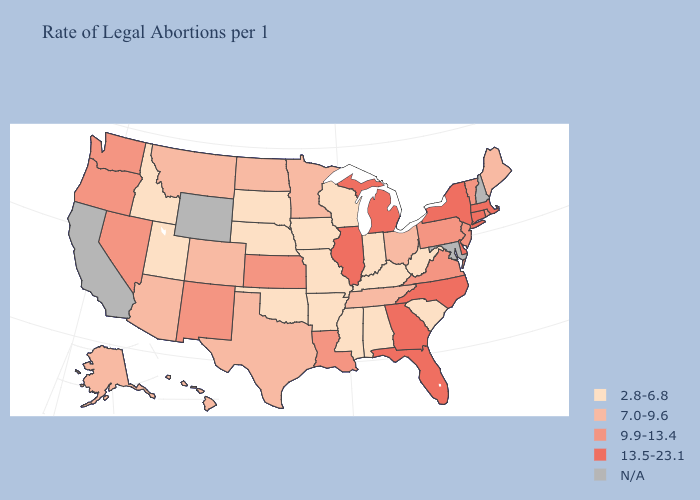Which states hav the highest value in the MidWest?
Answer briefly. Illinois, Michigan. Which states have the lowest value in the Northeast?
Keep it brief. Maine. What is the lowest value in states that border New Mexico?
Quick response, please. 2.8-6.8. What is the highest value in the West ?
Quick response, please. 9.9-13.4. Name the states that have a value in the range 7.0-9.6?
Keep it brief. Alaska, Arizona, Colorado, Hawaii, Maine, Minnesota, Montana, North Dakota, Ohio, Tennessee, Texas. Among the states that border New Mexico , which have the highest value?
Be succinct. Arizona, Colorado, Texas. Which states hav the highest value in the West?
Answer briefly. Nevada, New Mexico, Oregon, Washington. What is the value of Arkansas?
Short answer required. 2.8-6.8. Is the legend a continuous bar?
Be succinct. No. Does Iowa have the lowest value in the USA?
Be succinct. Yes. Name the states that have a value in the range 7.0-9.6?
Answer briefly. Alaska, Arizona, Colorado, Hawaii, Maine, Minnesota, Montana, North Dakota, Ohio, Tennessee, Texas. Does Hawaii have the highest value in the USA?
Give a very brief answer. No. Does Florida have the highest value in the USA?
Be succinct. Yes. Among the states that border Iowa , does Illinois have the lowest value?
Short answer required. No. Does the map have missing data?
Short answer required. Yes. 